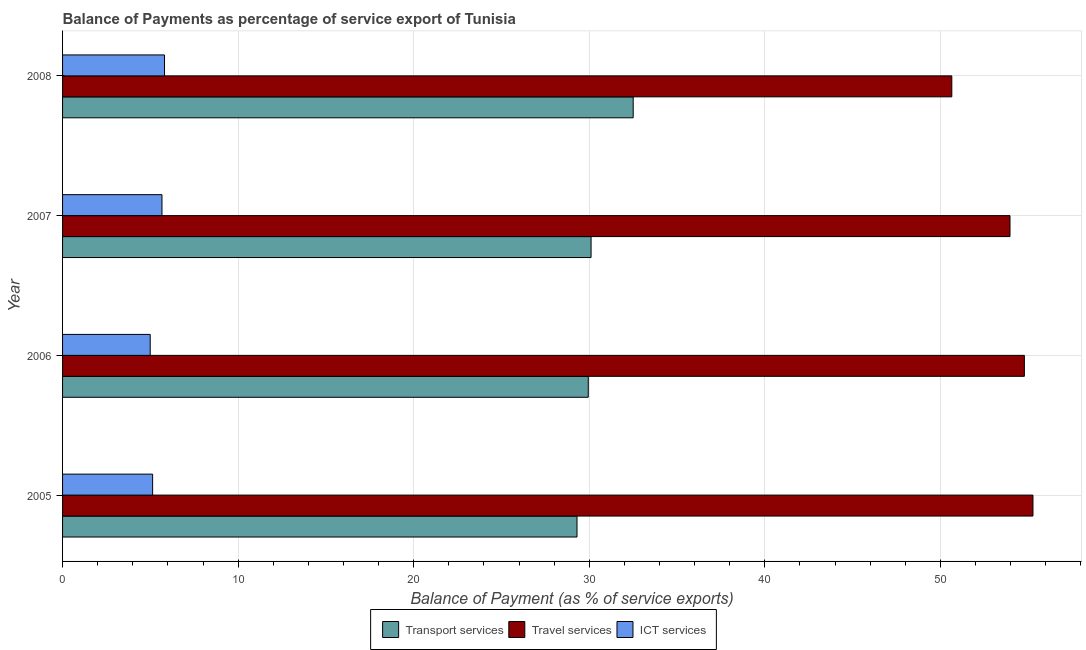What is the balance of payment of travel services in 2008?
Make the answer very short. 50.65. Across all years, what is the maximum balance of payment of transport services?
Your answer should be very brief. 32.5. Across all years, what is the minimum balance of payment of transport services?
Your answer should be compact. 29.3. In which year was the balance of payment of ict services maximum?
Offer a terse response. 2008. In which year was the balance of payment of ict services minimum?
Your answer should be very brief. 2006. What is the total balance of payment of ict services in the graph?
Give a very brief answer. 21.59. What is the difference between the balance of payment of travel services in 2007 and that in 2008?
Your answer should be compact. 3.31. What is the difference between the balance of payment of transport services in 2006 and the balance of payment of ict services in 2007?
Your answer should be very brief. 24.28. What is the average balance of payment of travel services per year?
Offer a very short reply. 53.66. In the year 2005, what is the difference between the balance of payment of travel services and balance of payment of ict services?
Offer a terse response. 50.14. What is the difference between the highest and the second highest balance of payment of travel services?
Provide a short and direct response. 0.49. What is the difference between the highest and the lowest balance of payment of travel services?
Provide a short and direct response. 4.62. In how many years, is the balance of payment of ict services greater than the average balance of payment of ict services taken over all years?
Make the answer very short. 2. Is the sum of the balance of payment of transport services in 2005 and 2006 greater than the maximum balance of payment of travel services across all years?
Make the answer very short. Yes. What does the 1st bar from the top in 2006 represents?
Offer a very short reply. ICT services. What does the 2nd bar from the bottom in 2008 represents?
Offer a very short reply. Travel services. Is it the case that in every year, the sum of the balance of payment of transport services and balance of payment of travel services is greater than the balance of payment of ict services?
Your answer should be compact. Yes. How many bars are there?
Your answer should be compact. 12. Are all the bars in the graph horizontal?
Provide a succinct answer. Yes. How many years are there in the graph?
Provide a short and direct response. 4. Are the values on the major ticks of X-axis written in scientific E-notation?
Your answer should be compact. No. How many legend labels are there?
Ensure brevity in your answer.  3. How are the legend labels stacked?
Offer a terse response. Horizontal. What is the title of the graph?
Make the answer very short. Balance of Payments as percentage of service export of Tunisia. What is the label or title of the X-axis?
Your answer should be compact. Balance of Payment (as % of service exports). What is the Balance of Payment (as % of service exports) of Transport services in 2005?
Provide a short and direct response. 29.3. What is the Balance of Payment (as % of service exports) of Travel services in 2005?
Your answer should be compact. 55.27. What is the Balance of Payment (as % of service exports) in ICT services in 2005?
Make the answer very short. 5.13. What is the Balance of Payment (as % of service exports) in Transport services in 2006?
Your response must be concise. 29.94. What is the Balance of Payment (as % of service exports) in Travel services in 2006?
Your answer should be compact. 54.78. What is the Balance of Payment (as % of service exports) of ICT services in 2006?
Offer a very short reply. 4.99. What is the Balance of Payment (as % of service exports) of Transport services in 2007?
Keep it short and to the point. 30.1. What is the Balance of Payment (as % of service exports) in Travel services in 2007?
Ensure brevity in your answer.  53.96. What is the Balance of Payment (as % of service exports) of ICT services in 2007?
Provide a short and direct response. 5.66. What is the Balance of Payment (as % of service exports) in Transport services in 2008?
Ensure brevity in your answer.  32.5. What is the Balance of Payment (as % of service exports) of Travel services in 2008?
Provide a short and direct response. 50.65. What is the Balance of Payment (as % of service exports) of ICT services in 2008?
Provide a short and direct response. 5.81. Across all years, what is the maximum Balance of Payment (as % of service exports) of Transport services?
Your answer should be very brief. 32.5. Across all years, what is the maximum Balance of Payment (as % of service exports) in Travel services?
Offer a terse response. 55.27. Across all years, what is the maximum Balance of Payment (as % of service exports) of ICT services?
Your answer should be very brief. 5.81. Across all years, what is the minimum Balance of Payment (as % of service exports) of Transport services?
Offer a terse response. 29.3. Across all years, what is the minimum Balance of Payment (as % of service exports) in Travel services?
Ensure brevity in your answer.  50.65. Across all years, what is the minimum Balance of Payment (as % of service exports) in ICT services?
Provide a short and direct response. 4.99. What is the total Balance of Payment (as % of service exports) in Transport services in the graph?
Provide a short and direct response. 121.84. What is the total Balance of Payment (as % of service exports) in Travel services in the graph?
Make the answer very short. 214.66. What is the total Balance of Payment (as % of service exports) in ICT services in the graph?
Provide a succinct answer. 21.59. What is the difference between the Balance of Payment (as % of service exports) of Transport services in 2005 and that in 2006?
Your answer should be compact. -0.64. What is the difference between the Balance of Payment (as % of service exports) in Travel services in 2005 and that in 2006?
Offer a very short reply. 0.49. What is the difference between the Balance of Payment (as % of service exports) of ICT services in 2005 and that in 2006?
Provide a succinct answer. 0.14. What is the difference between the Balance of Payment (as % of service exports) of Transport services in 2005 and that in 2007?
Provide a succinct answer. -0.8. What is the difference between the Balance of Payment (as % of service exports) in Travel services in 2005 and that in 2007?
Provide a succinct answer. 1.31. What is the difference between the Balance of Payment (as % of service exports) of ICT services in 2005 and that in 2007?
Provide a succinct answer. -0.53. What is the difference between the Balance of Payment (as % of service exports) in Transport services in 2005 and that in 2008?
Provide a succinct answer. -3.2. What is the difference between the Balance of Payment (as % of service exports) in Travel services in 2005 and that in 2008?
Your answer should be very brief. 4.62. What is the difference between the Balance of Payment (as % of service exports) of ICT services in 2005 and that in 2008?
Give a very brief answer. -0.68. What is the difference between the Balance of Payment (as % of service exports) in Transport services in 2006 and that in 2007?
Provide a short and direct response. -0.16. What is the difference between the Balance of Payment (as % of service exports) in Travel services in 2006 and that in 2007?
Make the answer very short. 0.82. What is the difference between the Balance of Payment (as % of service exports) in ICT services in 2006 and that in 2007?
Provide a succinct answer. -0.67. What is the difference between the Balance of Payment (as % of service exports) of Transport services in 2006 and that in 2008?
Make the answer very short. -2.56. What is the difference between the Balance of Payment (as % of service exports) of Travel services in 2006 and that in 2008?
Provide a short and direct response. 4.13. What is the difference between the Balance of Payment (as % of service exports) in ICT services in 2006 and that in 2008?
Your answer should be very brief. -0.82. What is the difference between the Balance of Payment (as % of service exports) of Transport services in 2007 and that in 2008?
Offer a terse response. -2.4. What is the difference between the Balance of Payment (as % of service exports) of Travel services in 2007 and that in 2008?
Provide a short and direct response. 3.31. What is the difference between the Balance of Payment (as % of service exports) in ICT services in 2007 and that in 2008?
Give a very brief answer. -0.14. What is the difference between the Balance of Payment (as % of service exports) of Transport services in 2005 and the Balance of Payment (as % of service exports) of Travel services in 2006?
Make the answer very short. -25.48. What is the difference between the Balance of Payment (as % of service exports) in Transport services in 2005 and the Balance of Payment (as % of service exports) in ICT services in 2006?
Provide a succinct answer. 24.31. What is the difference between the Balance of Payment (as % of service exports) of Travel services in 2005 and the Balance of Payment (as % of service exports) of ICT services in 2006?
Your answer should be compact. 50.28. What is the difference between the Balance of Payment (as % of service exports) of Transport services in 2005 and the Balance of Payment (as % of service exports) of Travel services in 2007?
Ensure brevity in your answer.  -24.66. What is the difference between the Balance of Payment (as % of service exports) of Transport services in 2005 and the Balance of Payment (as % of service exports) of ICT services in 2007?
Your answer should be very brief. 23.64. What is the difference between the Balance of Payment (as % of service exports) in Travel services in 2005 and the Balance of Payment (as % of service exports) in ICT services in 2007?
Your answer should be very brief. 49.61. What is the difference between the Balance of Payment (as % of service exports) in Transport services in 2005 and the Balance of Payment (as % of service exports) in Travel services in 2008?
Ensure brevity in your answer.  -21.35. What is the difference between the Balance of Payment (as % of service exports) of Transport services in 2005 and the Balance of Payment (as % of service exports) of ICT services in 2008?
Provide a succinct answer. 23.49. What is the difference between the Balance of Payment (as % of service exports) in Travel services in 2005 and the Balance of Payment (as % of service exports) in ICT services in 2008?
Ensure brevity in your answer.  49.46. What is the difference between the Balance of Payment (as % of service exports) in Transport services in 2006 and the Balance of Payment (as % of service exports) in Travel services in 2007?
Offer a terse response. -24.02. What is the difference between the Balance of Payment (as % of service exports) of Transport services in 2006 and the Balance of Payment (as % of service exports) of ICT services in 2007?
Your response must be concise. 24.28. What is the difference between the Balance of Payment (as % of service exports) of Travel services in 2006 and the Balance of Payment (as % of service exports) of ICT services in 2007?
Ensure brevity in your answer.  49.12. What is the difference between the Balance of Payment (as % of service exports) in Transport services in 2006 and the Balance of Payment (as % of service exports) in Travel services in 2008?
Your answer should be compact. -20.71. What is the difference between the Balance of Payment (as % of service exports) in Transport services in 2006 and the Balance of Payment (as % of service exports) in ICT services in 2008?
Your answer should be very brief. 24.14. What is the difference between the Balance of Payment (as % of service exports) of Travel services in 2006 and the Balance of Payment (as % of service exports) of ICT services in 2008?
Your answer should be compact. 48.97. What is the difference between the Balance of Payment (as % of service exports) in Transport services in 2007 and the Balance of Payment (as % of service exports) in Travel services in 2008?
Your response must be concise. -20.55. What is the difference between the Balance of Payment (as % of service exports) of Transport services in 2007 and the Balance of Payment (as % of service exports) of ICT services in 2008?
Give a very brief answer. 24.29. What is the difference between the Balance of Payment (as % of service exports) of Travel services in 2007 and the Balance of Payment (as % of service exports) of ICT services in 2008?
Your response must be concise. 48.15. What is the average Balance of Payment (as % of service exports) of Transport services per year?
Your answer should be very brief. 30.46. What is the average Balance of Payment (as % of service exports) in Travel services per year?
Provide a succinct answer. 53.66. What is the average Balance of Payment (as % of service exports) in ICT services per year?
Provide a succinct answer. 5.4. In the year 2005, what is the difference between the Balance of Payment (as % of service exports) of Transport services and Balance of Payment (as % of service exports) of Travel services?
Your answer should be compact. -25.97. In the year 2005, what is the difference between the Balance of Payment (as % of service exports) in Transport services and Balance of Payment (as % of service exports) in ICT services?
Your answer should be very brief. 24.17. In the year 2005, what is the difference between the Balance of Payment (as % of service exports) of Travel services and Balance of Payment (as % of service exports) of ICT services?
Ensure brevity in your answer.  50.14. In the year 2006, what is the difference between the Balance of Payment (as % of service exports) of Transport services and Balance of Payment (as % of service exports) of Travel services?
Offer a terse response. -24.84. In the year 2006, what is the difference between the Balance of Payment (as % of service exports) in Transport services and Balance of Payment (as % of service exports) in ICT services?
Provide a succinct answer. 24.95. In the year 2006, what is the difference between the Balance of Payment (as % of service exports) of Travel services and Balance of Payment (as % of service exports) of ICT services?
Make the answer very short. 49.79. In the year 2007, what is the difference between the Balance of Payment (as % of service exports) of Transport services and Balance of Payment (as % of service exports) of Travel services?
Offer a terse response. -23.86. In the year 2007, what is the difference between the Balance of Payment (as % of service exports) of Transport services and Balance of Payment (as % of service exports) of ICT services?
Make the answer very short. 24.44. In the year 2007, what is the difference between the Balance of Payment (as % of service exports) of Travel services and Balance of Payment (as % of service exports) of ICT services?
Keep it short and to the point. 48.3. In the year 2008, what is the difference between the Balance of Payment (as % of service exports) in Transport services and Balance of Payment (as % of service exports) in Travel services?
Your answer should be very brief. -18.15. In the year 2008, what is the difference between the Balance of Payment (as % of service exports) in Transport services and Balance of Payment (as % of service exports) in ICT services?
Give a very brief answer. 26.69. In the year 2008, what is the difference between the Balance of Payment (as % of service exports) in Travel services and Balance of Payment (as % of service exports) in ICT services?
Offer a terse response. 44.84. What is the ratio of the Balance of Payment (as % of service exports) of Transport services in 2005 to that in 2006?
Ensure brevity in your answer.  0.98. What is the ratio of the Balance of Payment (as % of service exports) in Travel services in 2005 to that in 2006?
Provide a short and direct response. 1.01. What is the ratio of the Balance of Payment (as % of service exports) in ICT services in 2005 to that in 2006?
Your response must be concise. 1.03. What is the ratio of the Balance of Payment (as % of service exports) in Transport services in 2005 to that in 2007?
Ensure brevity in your answer.  0.97. What is the ratio of the Balance of Payment (as % of service exports) of Travel services in 2005 to that in 2007?
Provide a short and direct response. 1.02. What is the ratio of the Balance of Payment (as % of service exports) in ICT services in 2005 to that in 2007?
Your response must be concise. 0.91. What is the ratio of the Balance of Payment (as % of service exports) in Transport services in 2005 to that in 2008?
Make the answer very short. 0.9. What is the ratio of the Balance of Payment (as % of service exports) in Travel services in 2005 to that in 2008?
Provide a succinct answer. 1.09. What is the ratio of the Balance of Payment (as % of service exports) of ICT services in 2005 to that in 2008?
Your answer should be compact. 0.88. What is the ratio of the Balance of Payment (as % of service exports) in Transport services in 2006 to that in 2007?
Make the answer very short. 0.99. What is the ratio of the Balance of Payment (as % of service exports) of Travel services in 2006 to that in 2007?
Keep it short and to the point. 1.02. What is the ratio of the Balance of Payment (as % of service exports) of ICT services in 2006 to that in 2007?
Your answer should be compact. 0.88. What is the ratio of the Balance of Payment (as % of service exports) in Transport services in 2006 to that in 2008?
Offer a very short reply. 0.92. What is the ratio of the Balance of Payment (as % of service exports) of Travel services in 2006 to that in 2008?
Make the answer very short. 1.08. What is the ratio of the Balance of Payment (as % of service exports) in ICT services in 2006 to that in 2008?
Your answer should be compact. 0.86. What is the ratio of the Balance of Payment (as % of service exports) in Transport services in 2007 to that in 2008?
Give a very brief answer. 0.93. What is the ratio of the Balance of Payment (as % of service exports) of Travel services in 2007 to that in 2008?
Give a very brief answer. 1.07. What is the ratio of the Balance of Payment (as % of service exports) in ICT services in 2007 to that in 2008?
Ensure brevity in your answer.  0.98. What is the difference between the highest and the second highest Balance of Payment (as % of service exports) in Transport services?
Your answer should be very brief. 2.4. What is the difference between the highest and the second highest Balance of Payment (as % of service exports) of Travel services?
Offer a very short reply. 0.49. What is the difference between the highest and the second highest Balance of Payment (as % of service exports) in ICT services?
Keep it short and to the point. 0.14. What is the difference between the highest and the lowest Balance of Payment (as % of service exports) of Transport services?
Offer a terse response. 3.2. What is the difference between the highest and the lowest Balance of Payment (as % of service exports) in Travel services?
Your answer should be compact. 4.62. What is the difference between the highest and the lowest Balance of Payment (as % of service exports) in ICT services?
Your answer should be compact. 0.82. 